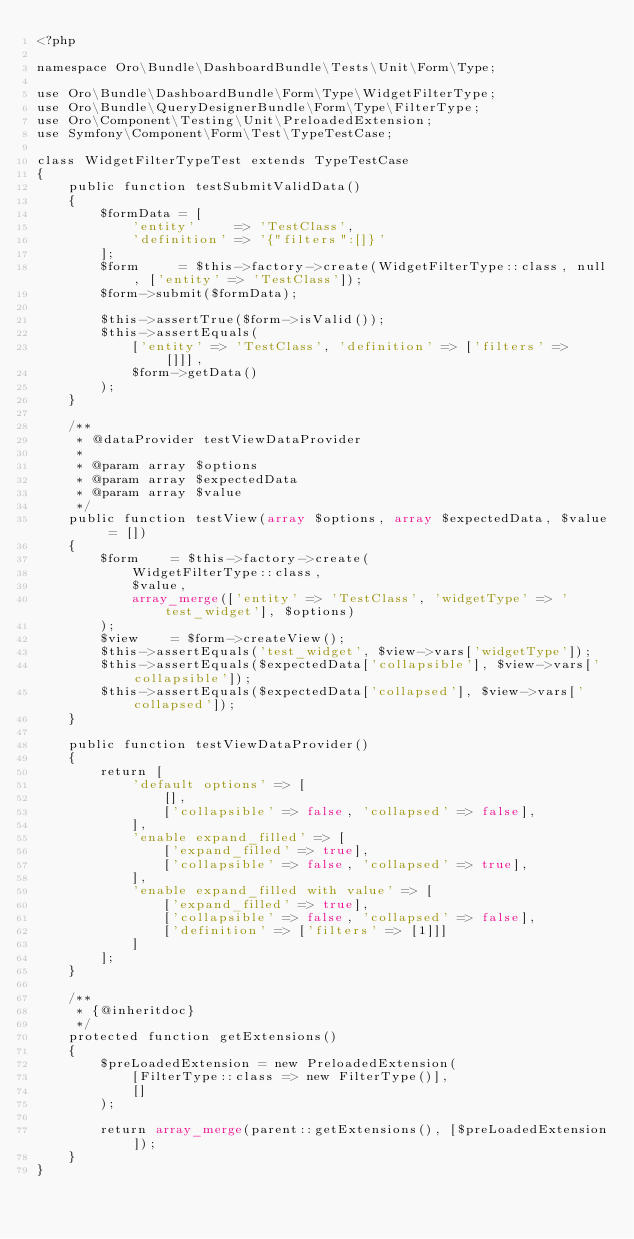Convert code to text. <code><loc_0><loc_0><loc_500><loc_500><_PHP_><?php

namespace Oro\Bundle\DashboardBundle\Tests\Unit\Form\Type;

use Oro\Bundle\DashboardBundle\Form\Type\WidgetFilterType;
use Oro\Bundle\QueryDesignerBundle\Form\Type\FilterType;
use Oro\Component\Testing\Unit\PreloadedExtension;
use Symfony\Component\Form\Test\TypeTestCase;

class WidgetFilterTypeTest extends TypeTestCase
{
    public function testSubmitValidData()
    {
        $formData = [
            'entity'     => 'TestClass',
            'definition' => '{"filters":[]}'
        ];
        $form     = $this->factory->create(WidgetFilterType::class, null, ['entity' => 'TestClass']);
        $form->submit($formData);

        $this->assertTrue($form->isValid());
        $this->assertEquals(
            ['entity' => 'TestClass', 'definition' => ['filters' => []]],
            $form->getData()
        );
    }

    /**
     * @dataProvider testViewDataProvider
     *
     * @param array $options
     * @param array $expectedData
     * @param array $value
     */
    public function testView(array $options, array $expectedData, $value = [])
    {
        $form    = $this->factory->create(
            WidgetFilterType::class,
            $value,
            array_merge(['entity' => 'TestClass', 'widgetType' => 'test_widget'], $options)
        );
        $view    = $form->createView();
        $this->assertEquals('test_widget', $view->vars['widgetType']);
        $this->assertEquals($expectedData['collapsible'], $view->vars['collapsible']);
        $this->assertEquals($expectedData['collapsed'], $view->vars['collapsed']);
    }

    public function testViewDataProvider()
    {
        return [
            'default options' => [
                [],
                ['collapsible' => false, 'collapsed' => false],
            ],
            'enable expand_filled' => [
                ['expand_filled' => true],
                ['collapsible' => false, 'collapsed' => true],
            ],
            'enable expand_filled with value' => [
                ['expand_filled' => true],
                ['collapsible' => false, 'collapsed' => false],
                ['definition' => ['filters' => [1]]]
            ]
        ];
    }

    /**
     * {@inheritdoc}
     */
    protected function getExtensions()
    {
        $preLoadedExtension = new PreloadedExtension(
            [FilterType::class => new FilterType()],
            []
        );

        return array_merge(parent::getExtensions(), [$preLoadedExtension]);
    }
}
</code> 